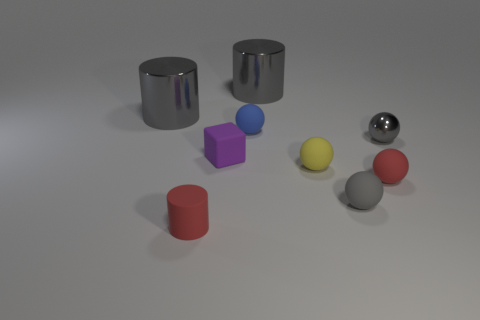There is a large object that is to the left of the small blue object; does it have the same shape as the large thing that is on the right side of the blue matte thing?
Your answer should be compact. Yes. Is there any other thing that has the same material as the purple object?
Your response must be concise. Yes. What is the red cylinder made of?
Provide a succinct answer. Rubber. What material is the gray ball behind the gray matte ball?
Ensure brevity in your answer.  Metal. Are there any other things that are the same color as the tiny matte cylinder?
Provide a succinct answer. Yes. The red object that is the same material as the tiny red cylinder is what size?
Ensure brevity in your answer.  Small. What number of tiny things are either gray shiny objects or spheres?
Provide a succinct answer. 5. What size is the gray metal cylinder on the left side of the big gray thing that is right of the tiny ball that is behind the metallic ball?
Make the answer very short. Large. How many red matte cylinders have the same size as the purple matte cube?
Provide a short and direct response. 1. What number of things are tiny red matte objects or cylinders behind the tiny red cylinder?
Offer a very short reply. 4. 